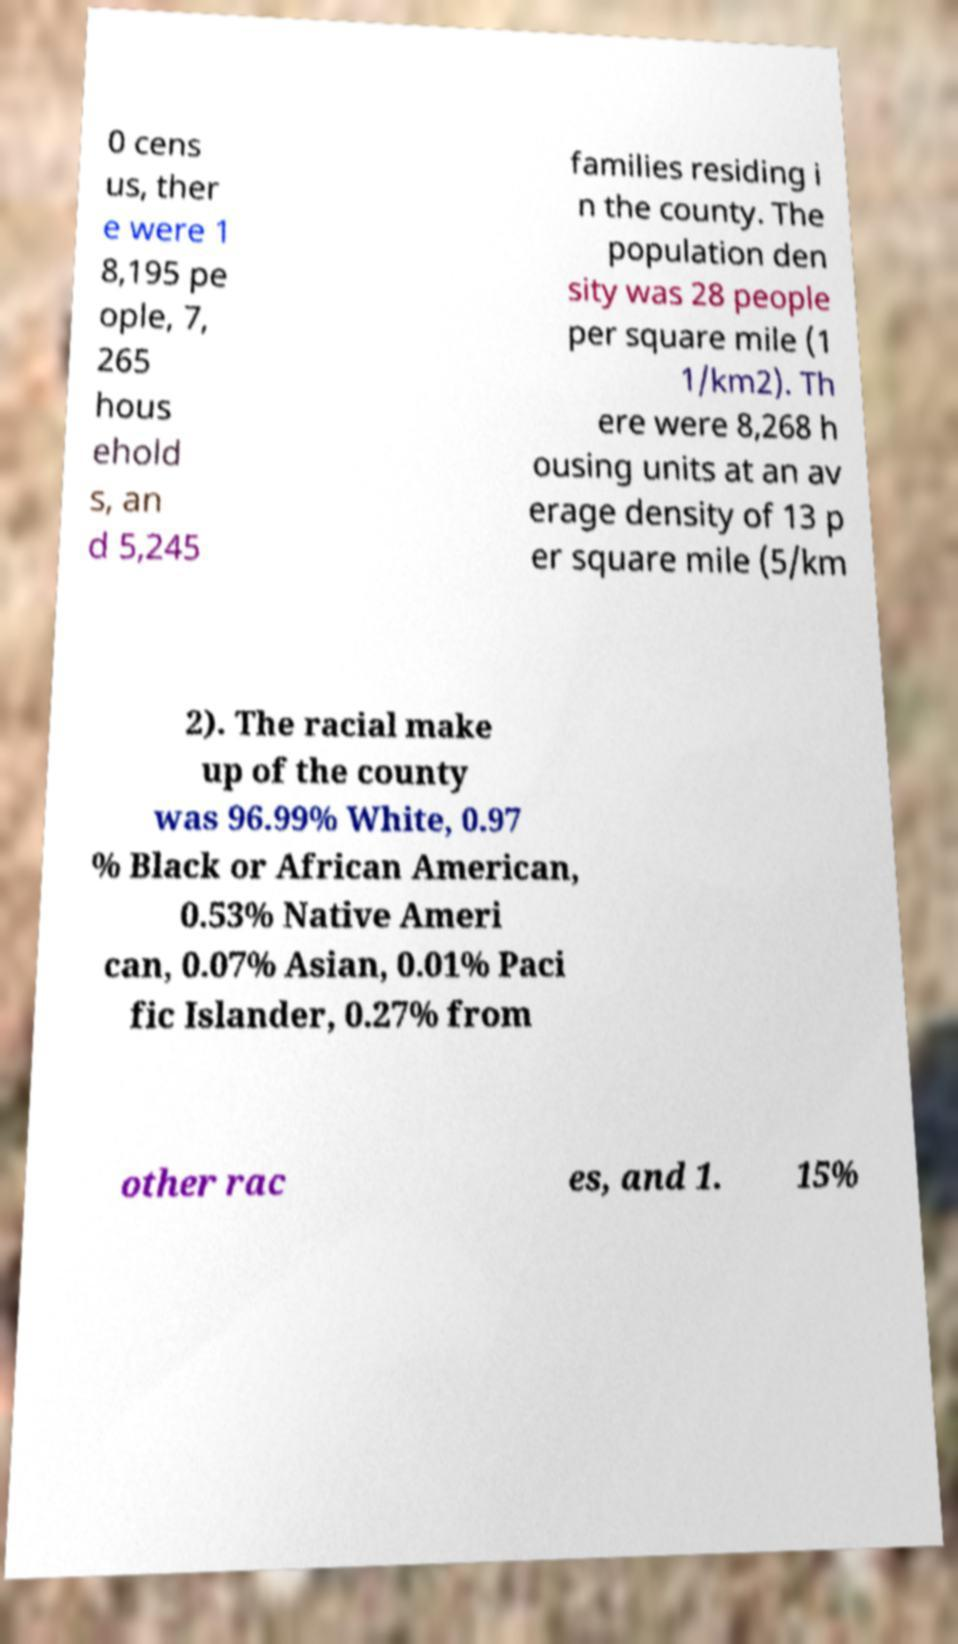Can you accurately transcribe the text from the provided image for me? 0 cens us, ther e were 1 8,195 pe ople, 7, 265 hous ehold s, an d 5,245 families residing i n the county. The population den sity was 28 people per square mile (1 1/km2). Th ere were 8,268 h ousing units at an av erage density of 13 p er square mile (5/km 2). The racial make up of the county was 96.99% White, 0.97 % Black or African American, 0.53% Native Ameri can, 0.07% Asian, 0.01% Paci fic Islander, 0.27% from other rac es, and 1. 15% 